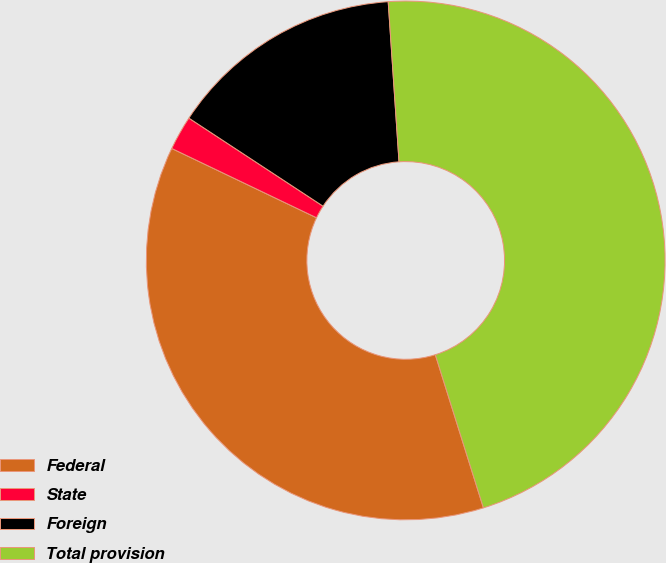Convert chart. <chart><loc_0><loc_0><loc_500><loc_500><pie_chart><fcel>Federal<fcel>State<fcel>Foreign<fcel>Total provision<nl><fcel>36.95%<fcel>2.14%<fcel>14.68%<fcel>46.23%<nl></chart> 